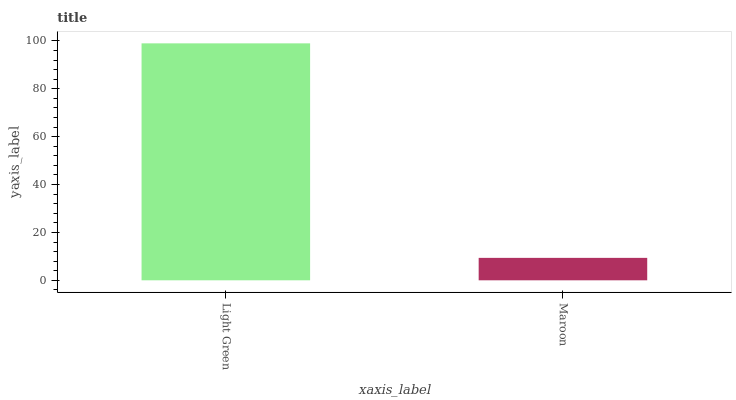Is Maroon the minimum?
Answer yes or no. Yes. Is Light Green the maximum?
Answer yes or no. Yes. Is Maroon the maximum?
Answer yes or no. No. Is Light Green greater than Maroon?
Answer yes or no. Yes. Is Maroon less than Light Green?
Answer yes or no. Yes. Is Maroon greater than Light Green?
Answer yes or no. No. Is Light Green less than Maroon?
Answer yes or no. No. Is Light Green the high median?
Answer yes or no. Yes. Is Maroon the low median?
Answer yes or no. Yes. Is Maroon the high median?
Answer yes or no. No. Is Light Green the low median?
Answer yes or no. No. 